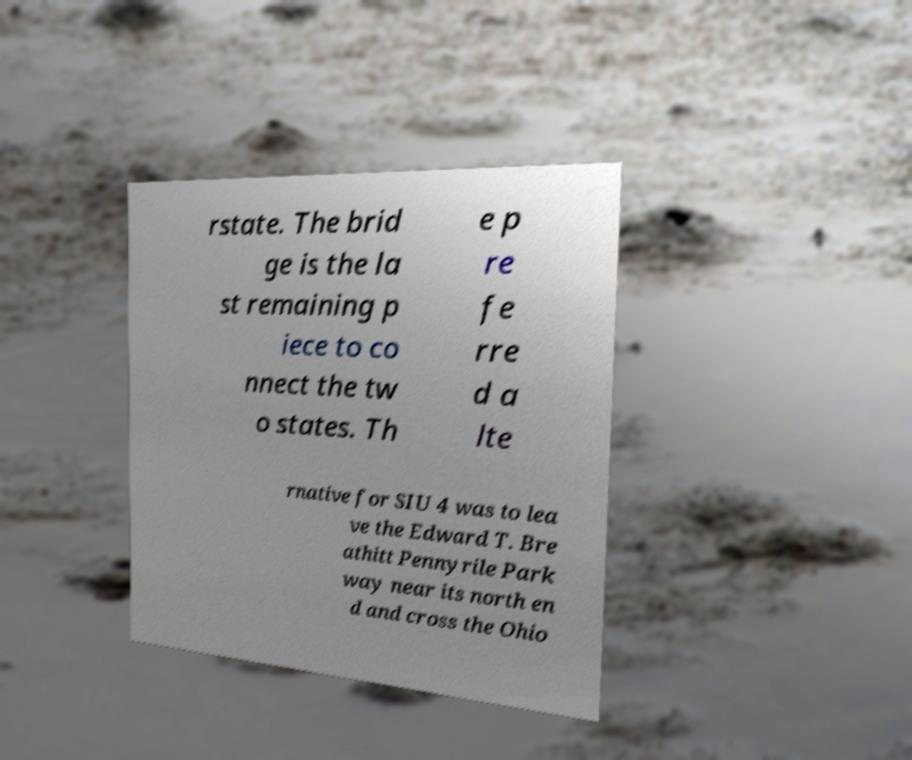Can you read and provide the text displayed in the image?This photo seems to have some interesting text. Can you extract and type it out for me? rstate. The brid ge is the la st remaining p iece to co nnect the tw o states. Th e p re fe rre d a lte rnative for SIU 4 was to lea ve the Edward T. Bre athitt Pennyrile Park way near its north en d and cross the Ohio 